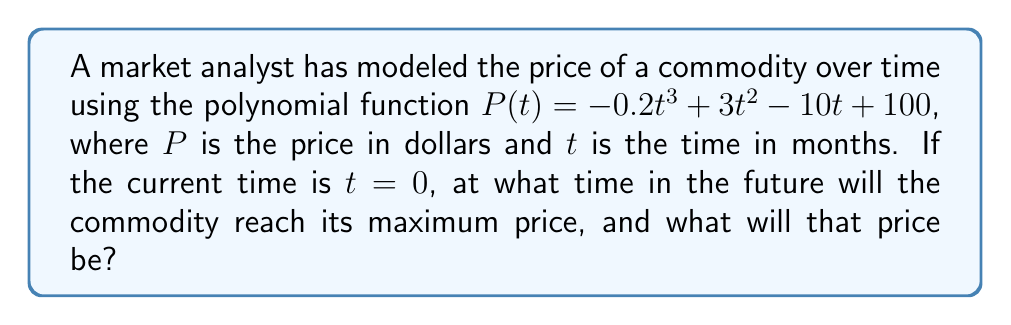Teach me how to tackle this problem. To find the maximum price and when it occurs, we need to follow these steps:

1) First, we need to find the derivative of $P(t)$:
   $$P'(t) = -0.6t^2 + 6t - 10$$

2) To find the critical points, set $P'(t) = 0$:
   $$-0.6t^2 + 6t - 10 = 0$$

3) This is a quadratic equation. We can solve it using the quadratic formula:
   $$t = \frac{-b \pm \sqrt{b^2 - 4ac}}{2a}$$
   where $a = -0.6$, $b = 6$, and $c = -10$

4) Plugging in the values:
   $$t = \frac{-6 \pm \sqrt{36 - 4(-0.6)(-10)}}{2(-0.6)}$$
   $$= \frac{-6 \pm \sqrt{36 - 24}}{-1.2}$$
   $$= \frac{-6 \pm \sqrt{12}}{-1.2}$$
   $$= \frac{-6 \pm 2\sqrt{3}}{-1.2}$$

5) This gives us two solutions:
   $$t_1 = \frac{-6 + 2\sqrt{3}}{-1.2} \approx 6.73$$
   $$t_2 = \frac{-6 - 2\sqrt{3}}{-1.2} \approx 3.27$$

6) To determine which of these is the maximum, we can check the second derivative:
   $$P''(t) = -1.2t + 6$$

7) At $t = 3.27$, $P''(3.27) = -1.2(3.27) + 6 = 2.08 > 0$, indicating a minimum.
   At $t = 6.73$, $P''(6.73) = -1.2(6.73) + 6 = -2.08 < 0$, indicating a maximum.

8) Therefore, the maximum occurs at $t \approx 6.73$ months.

9) To find the maximum price, we plug this value back into our original function:
   $$P(6.73) = -0.2(6.73)^3 + 3(6.73)^2 - 10(6.73) + 100 \approx 110.19$$
Answer: Maximum price of $110.19 occurs at 6.73 months. 